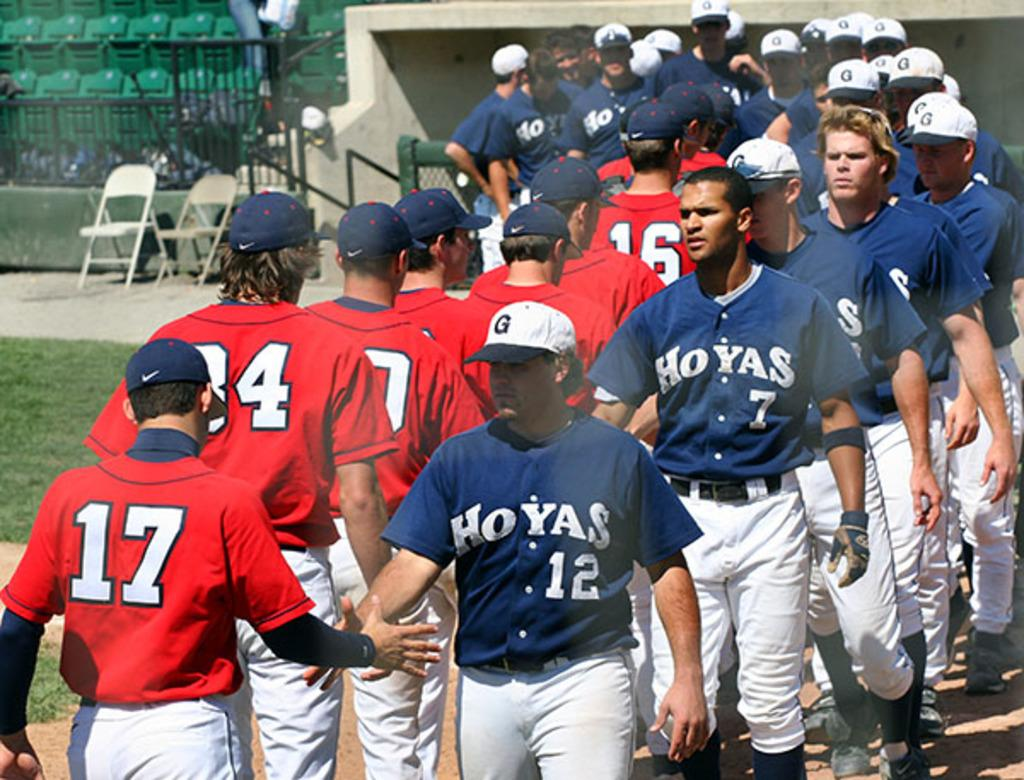<image>
Present a compact description of the photo's key features. some baseball jerseys with the name Hoyas on it 